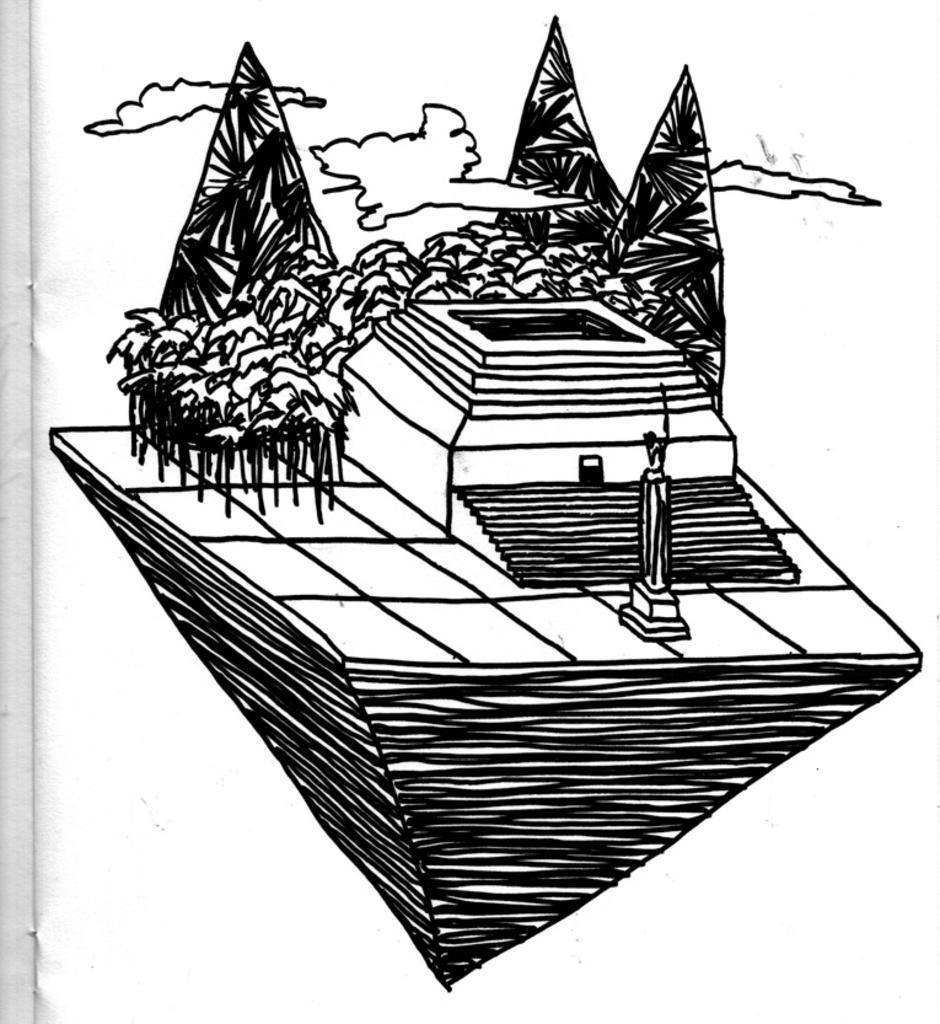How would you summarize this image in a sentence or two? In this picture I can see the design in the book. In the design I can see the mountain, trees, stairs, statues and clouds. 